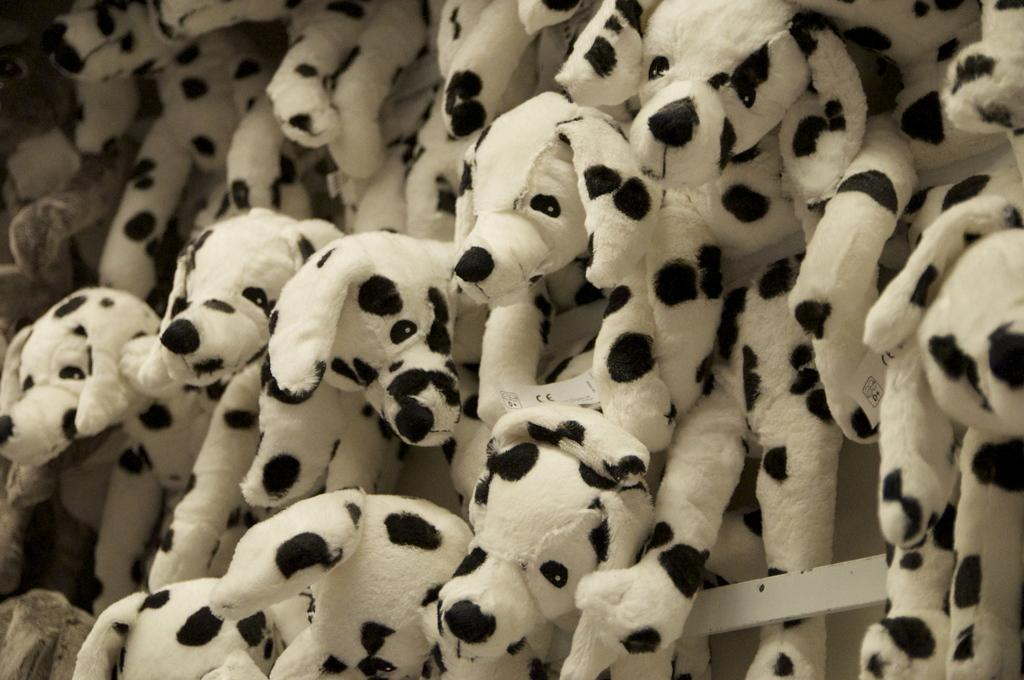What type of objects are present in the image? There are many dog toys in the image. What color scheme is used for the dog toys? The dog toys are in black and white. What type of glass instrument can be seen in the image? There is no glass instrument present in the image; it features many dog toys in black and white. 